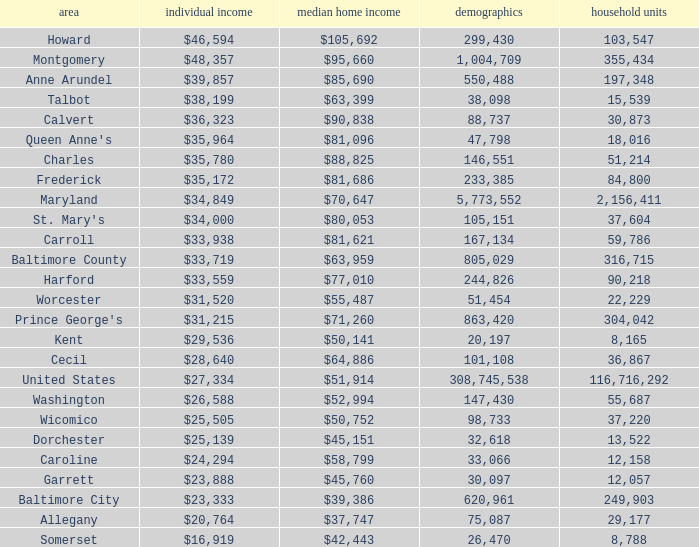What is the per capital income for Charles county? $35,780. 